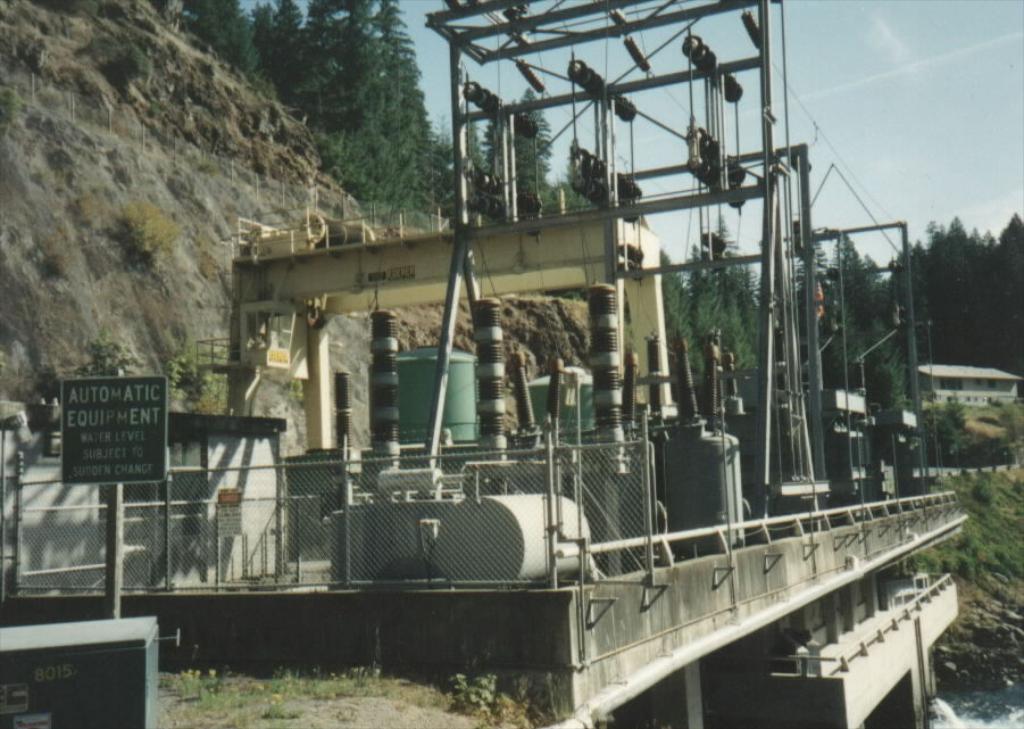In one or two sentences, can you explain what this image depicts? In this picture I can see the electronic equipment in front and I can see a board, on which there is something written. In the background I can see few plants, number of trees and a building. On the top of this picture I can see the sky. On the bottom right corner of this picture I can see the water. 